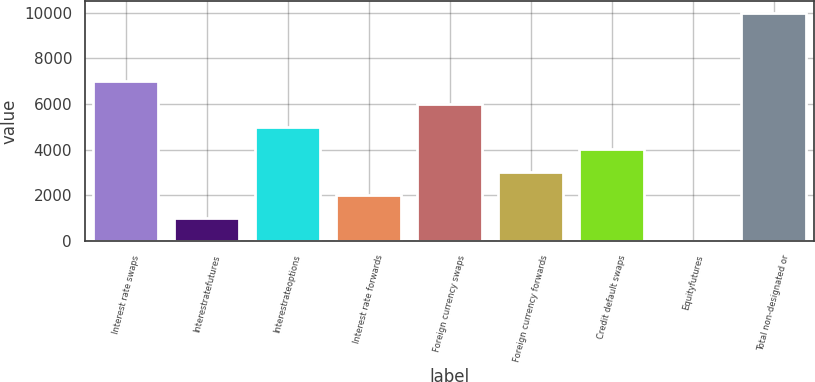Convert chart. <chart><loc_0><loc_0><loc_500><loc_500><bar_chart><fcel>Interest rate swaps<fcel>Interestratefutures<fcel>Interestrateoptions<fcel>Interest rate forwards<fcel>Foreign currency swaps<fcel>Foreign currency forwards<fcel>Credit default swaps<fcel>Equityfutures<fcel>Total non-designated or<nl><fcel>7003.8<fcel>1001.4<fcel>5003<fcel>2001.8<fcel>6003.4<fcel>3002.2<fcel>4002.6<fcel>1<fcel>10005<nl></chart> 